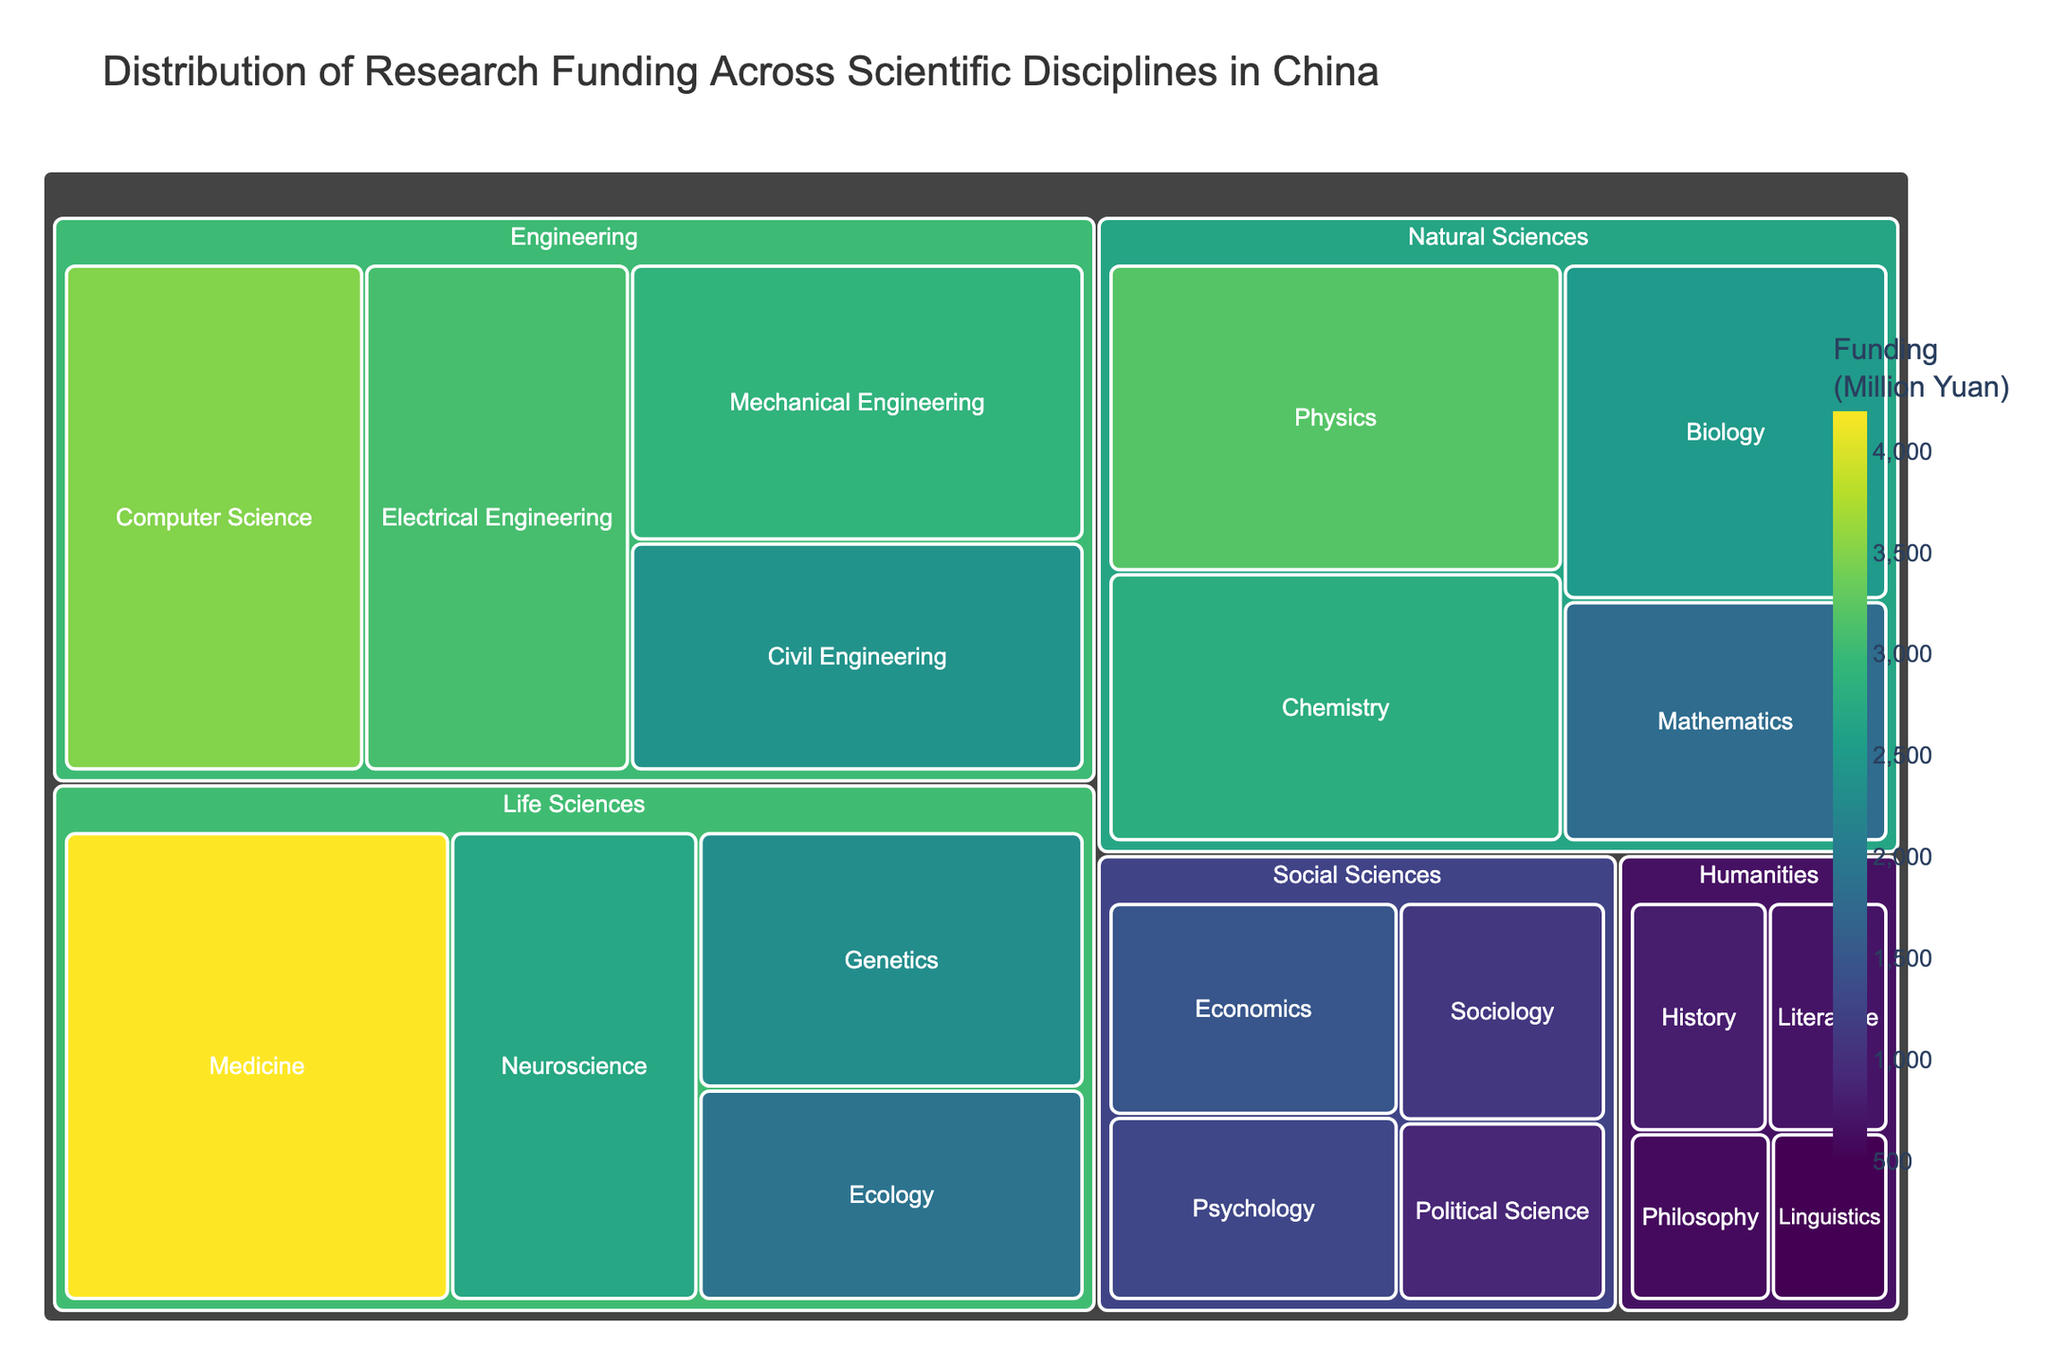What is the main theme of the treemap? The title of the treemap indicates that it illustrates the distribution of research funding across various scientific disciplines in China.
Answer: Distribution of research funding across scientific disciplines in China Which category received the highest research funding? By observing the size of the blocks, the "Life Sciences" category received the largest funding.
Answer: Life Sciences Which subcategory within the Natural Sciences category got the most funding? In the Natural Sciences section, the "Physics" subcategory has the largest block, indicating the highest funding.
Answer: Physics What is the total research funding allocated to the Social Sciences category? Adding up the funding amounts for Economics (1500), Psychology (1300), Sociology (1100), and Political Science (900) yields a total. 1500 + 1300 + 1100 + 900 = 4800 Million Yuan.
Answer: 4800 Million Yuan Compare the funding for Medicine and Civil Engineering. Which is greater and by how much? Medicine has 4200 Million Yuan, and Civil Engineering has 2400 Million Yuan. The difference is 4200 - 2400 = 1800 Million Yuan.
Answer: Medicine, by 1800 Million Yuan Which subcategory received the least funding, and how much was it? The smallest block across all subcategories belongs to "Linguistics" under the Humanities category, which received 500 Million Yuan.
Answer: Linguistics, 500 Million Yuan What is the average funding for subcategories within the Humanities category? The funding for subcategories in the Humanities are History (800), Literature (700), Philosophy (600), and Linguistics (500). Average funding: (800 + 700 + 600 + 500) / 4 = 2600 / 4 = 650 Million Yuan.
Answer: 650 Million Yuan Rank the funding of subcategories in the Engineering category from highest to lowest. The funding amounts are Computer Science (3500), Electrical Engineering (3100), Mechanical Engineering (2900), and Civil Engineering (2400). Ranking from highest to lowest: Computer Science, Electrical Engineering, Mechanical Engineering, Civil Engineering.
Answer: Computer Science, Electrical Engineering, Mechanical Engineering, Civil Engineering What proportion of the total funding is allocated to Biology within Natural Sciences? Biology received 2500 Million Yuan. The total funding for all categories can be summed up: (3200 + 2800 + 2500 + 1800 + 3500 + 3100 + 2900 + 2400 + 4200 + 2700 + 2300 + 1900 + 1500 + 1300 + 1100 + 900 + 800 + 700 + 600 + 500) = 50400 Million Yuan. Proportion for Biology: (2500 / 50400) * 100 ≈ 4.96%.
Answer: ~4.96% 